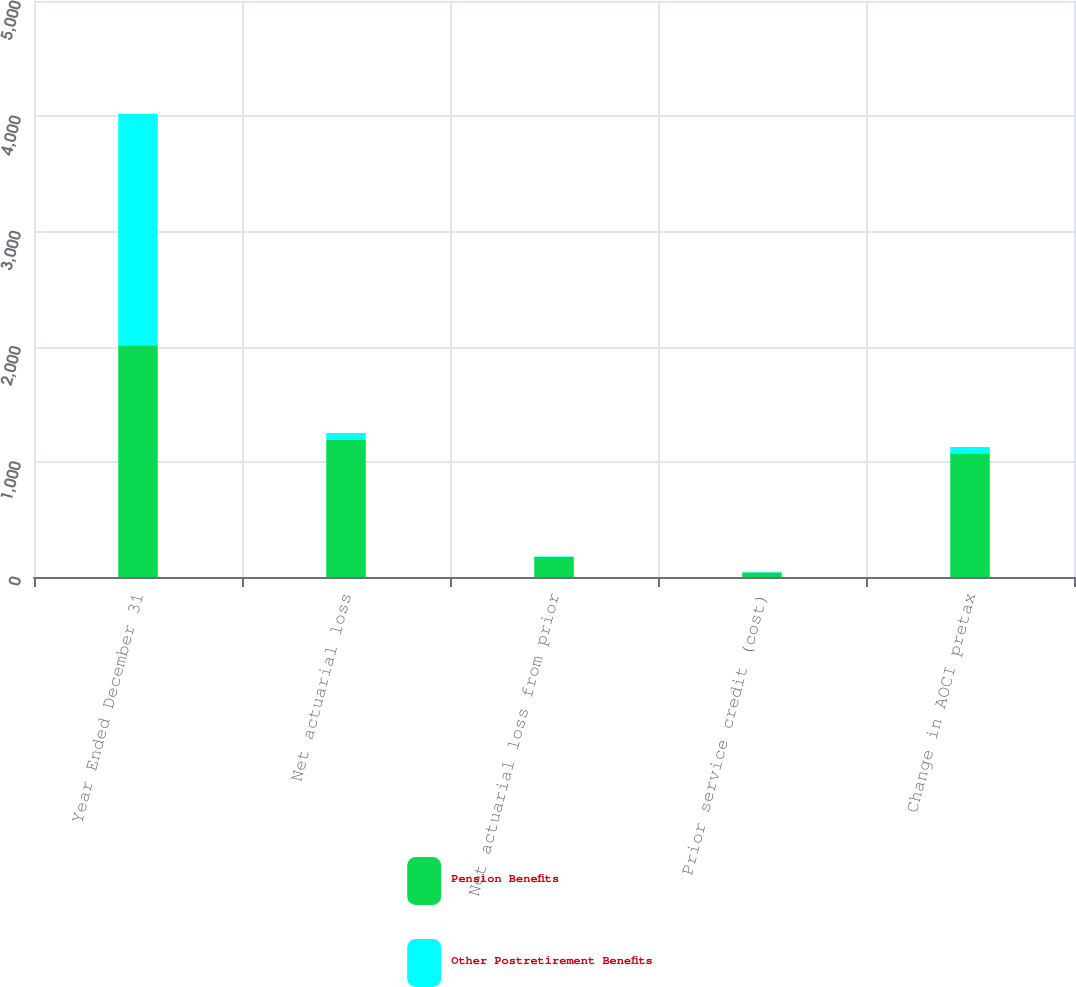Convert chart. <chart><loc_0><loc_0><loc_500><loc_500><stacked_bar_chart><ecel><fcel>Year Ended December 31<fcel>Net actuarial loss<fcel>Net actuarial loss from prior<fcel>Prior service credit (cost)<fcel>Change in AOCI pretax<nl><fcel>Pension Benefits<fcel>2011<fcel>1189<fcel>173<fcel>40<fcel>1075<nl><fcel>Other Postretirement Benefits<fcel>2011<fcel>61<fcel>4<fcel>6<fcel>54<nl></chart> 